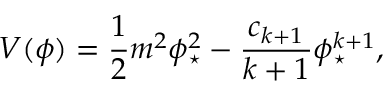<formula> <loc_0><loc_0><loc_500><loc_500>V ( \phi ) = \frac { 1 } { 2 } m ^ { 2 } \phi _ { ^ { * } } ^ { 2 } - \frac { c _ { k + 1 } } { k + 1 } \phi _ { ^ { * } } ^ { k + 1 } ,</formula> 